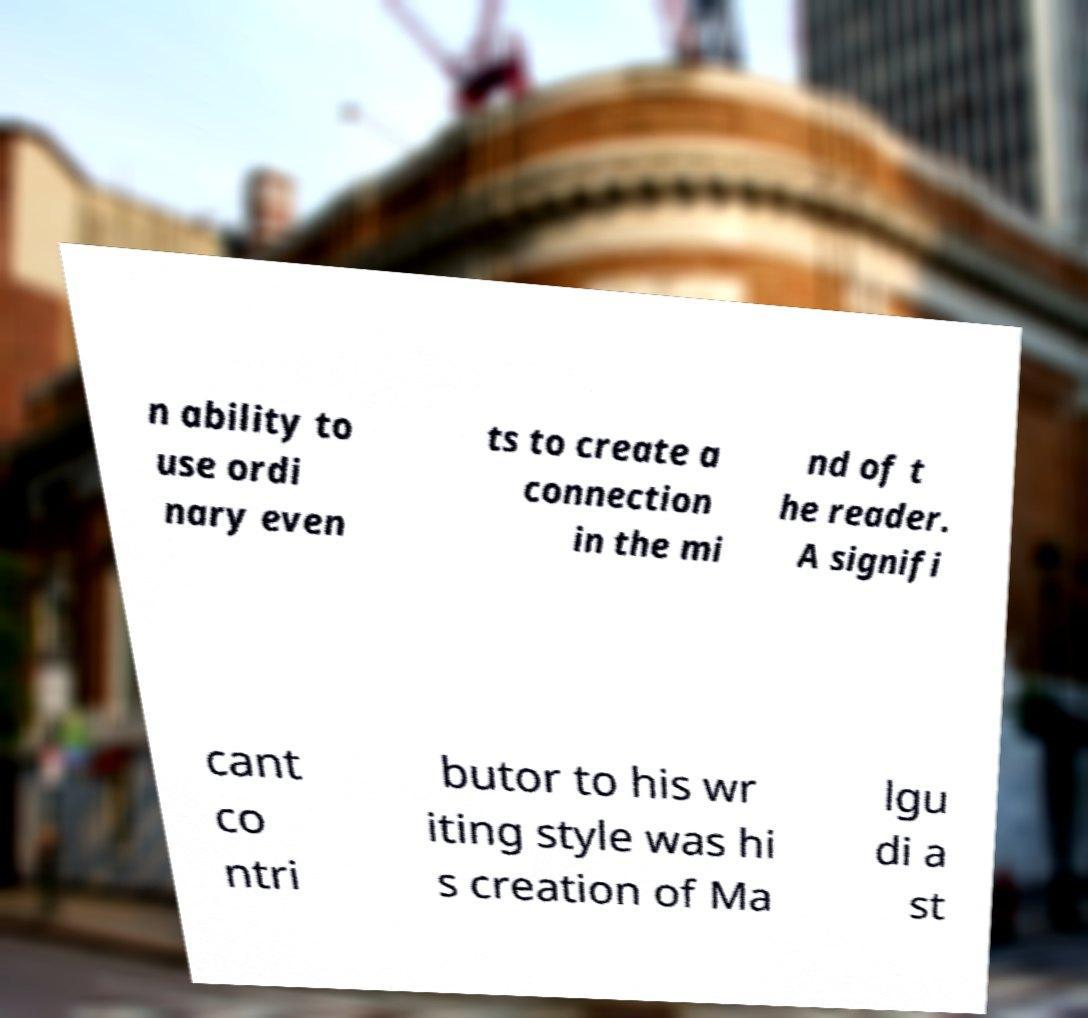Could you extract and type out the text from this image? n ability to use ordi nary even ts to create a connection in the mi nd of t he reader. A signifi cant co ntri butor to his wr iting style was hi s creation of Ma lgu di a st 